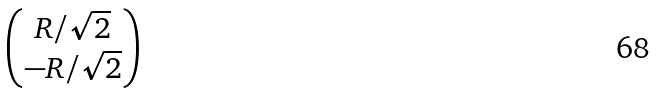Convert formula to latex. <formula><loc_0><loc_0><loc_500><loc_500>\begin{pmatrix} R / \sqrt { 2 } \\ - R / \sqrt { 2 } \end{pmatrix}</formula> 